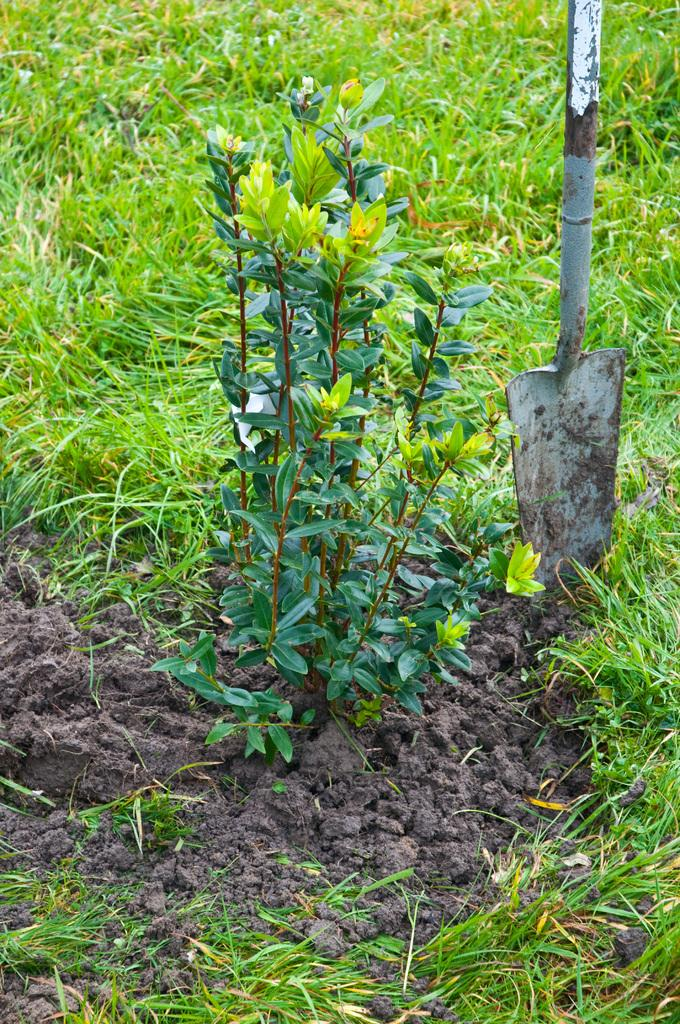What type of vegetation is in the center of the image? There is grass in the center of the image. What other natural element is present in the center of the image? There is a plant in the center of the image. What is the texture of the ground in the center of the image? There is mud in the center of the image. What type of object can be seen in the center of the image? There is a pole-like object in the center of the image. Can you describe any other objects in the center of the image? There are a few other objects in the center of the image. How many deer are visible in the image? There are no deer present in the image. What type of glove is being used to water the plant in the image? There is no glove or watering activity depicted in the image. 